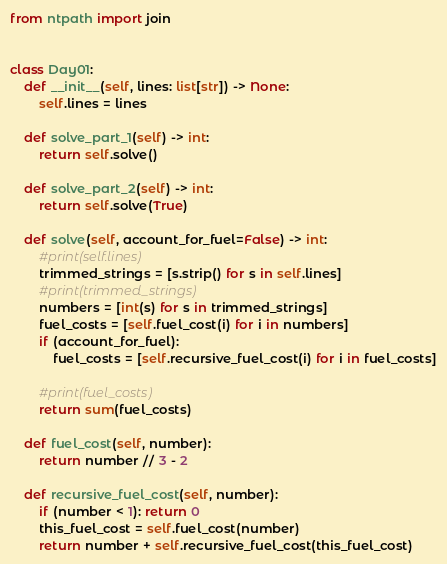Convert code to text. <code><loc_0><loc_0><loc_500><loc_500><_Python_>from ntpath import join


class Day01:
    def __init__(self, lines: list[str]) -> None:
        self.lines = lines

    def solve_part_1(self) -> int:
        return self.solve()

    def solve_part_2(self) -> int:
        return self.solve(True)

    def solve(self, account_for_fuel=False) -> int:
        #print(self.lines)
        trimmed_strings = [s.strip() for s in self.lines]
        #print(trimmed_strings)
        numbers = [int(s) for s in trimmed_strings]
        fuel_costs = [self.fuel_cost(i) for i in numbers]
        if (account_for_fuel):
            fuel_costs = [self.recursive_fuel_cost(i) for i in fuel_costs]

        #print(fuel_costs)
        return sum(fuel_costs)
        
    def fuel_cost(self, number):
        return number // 3 - 2

    def recursive_fuel_cost(self, number):
        if (number < 1): return 0
        this_fuel_cost = self.fuel_cost(number)
        return number + self.recursive_fuel_cost(this_fuel_cost)

</code> 